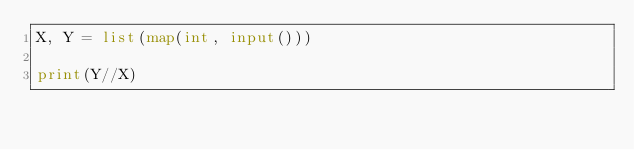<code> <loc_0><loc_0><loc_500><loc_500><_Python_>X, Y = list(map(int, input()))

print(Y//X)</code> 